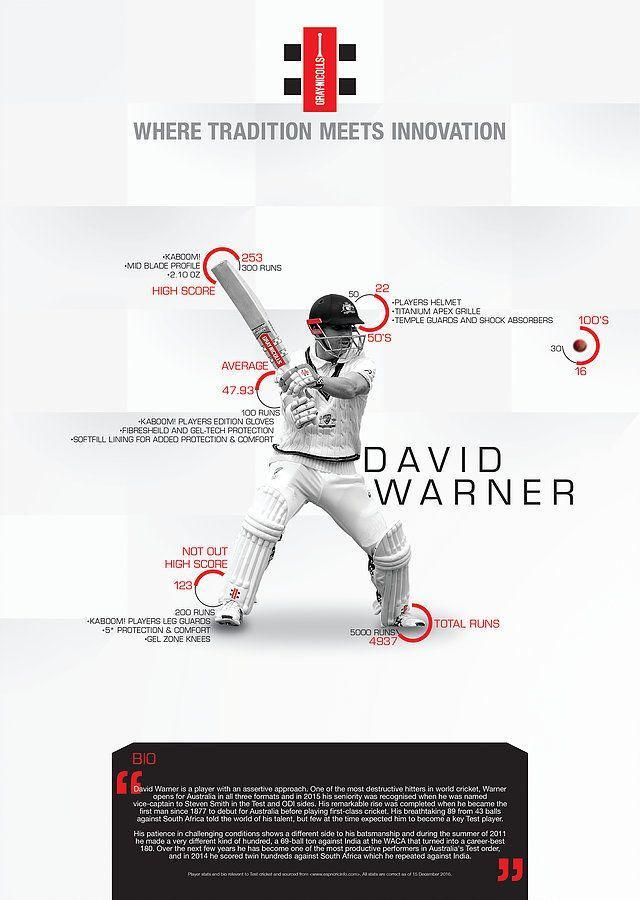What is the total run scored by David Warner?
Answer the question with a short phrase. 4937 